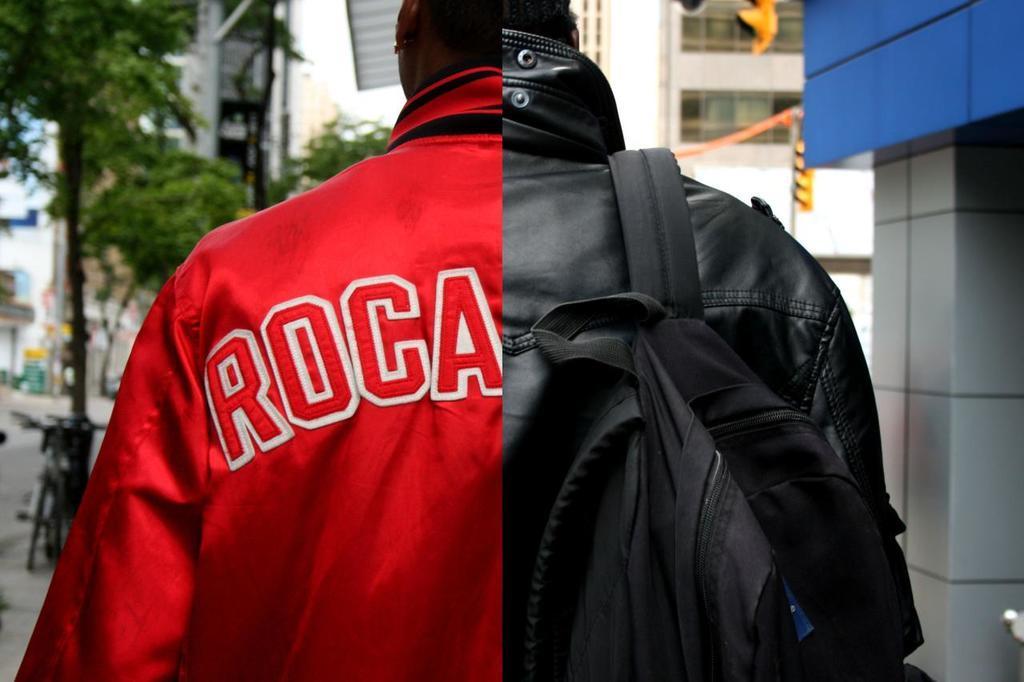Describe this image in one or two sentences. In the image we can see there is a image which is collage of two pictures and on the other side there is a person who is wearing a red colour jacket and on the right side there is a person who is wearing black colour jacket and carrying a black colour backpack. 